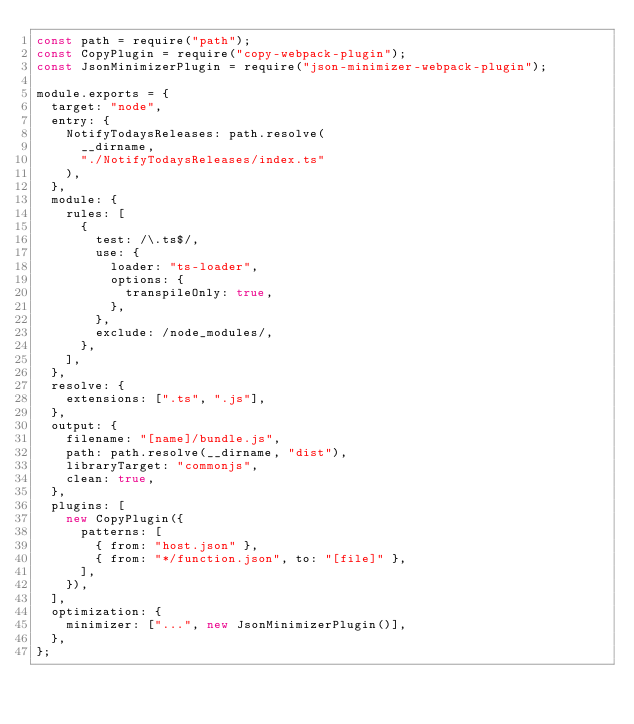<code> <loc_0><loc_0><loc_500><loc_500><_JavaScript_>const path = require("path");
const CopyPlugin = require("copy-webpack-plugin");
const JsonMinimizerPlugin = require("json-minimizer-webpack-plugin");

module.exports = {
  target: "node",
  entry: {
    NotifyTodaysReleases: path.resolve(
      __dirname,
      "./NotifyTodaysReleases/index.ts"
    ),
  },
  module: {
    rules: [
      {
        test: /\.ts$/,
        use: {
          loader: "ts-loader",
          options: {
            transpileOnly: true,
          },
        },
        exclude: /node_modules/,
      },
    ],
  },
  resolve: {
    extensions: [".ts", ".js"],
  },
  output: {
    filename: "[name]/bundle.js",
    path: path.resolve(__dirname, "dist"),
    libraryTarget: "commonjs",
    clean: true,
  },
  plugins: [
    new CopyPlugin({
      patterns: [
        { from: "host.json" },
        { from: "*/function.json", to: "[file]" },
      ],
    }),
  ],
  optimization: {
    minimizer: ["...", new JsonMinimizerPlugin()],
  },
};
</code> 